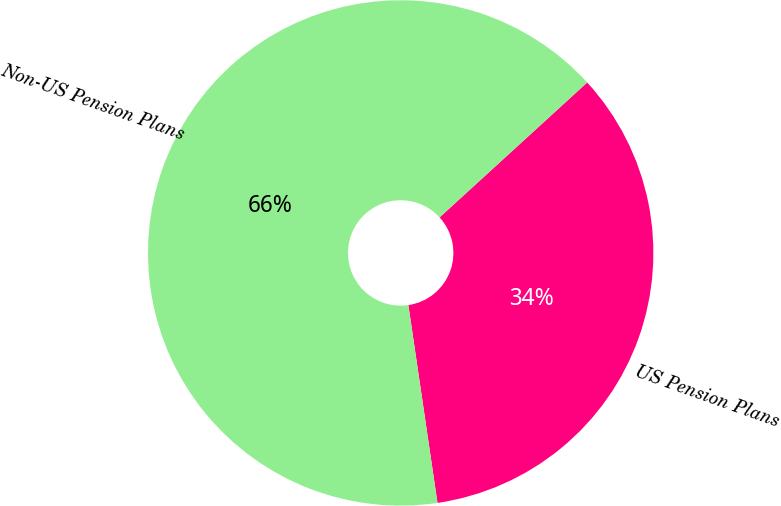<chart> <loc_0><loc_0><loc_500><loc_500><pie_chart><fcel>US Pension Plans<fcel>Non-US Pension Plans<nl><fcel>34.46%<fcel>65.54%<nl></chart> 